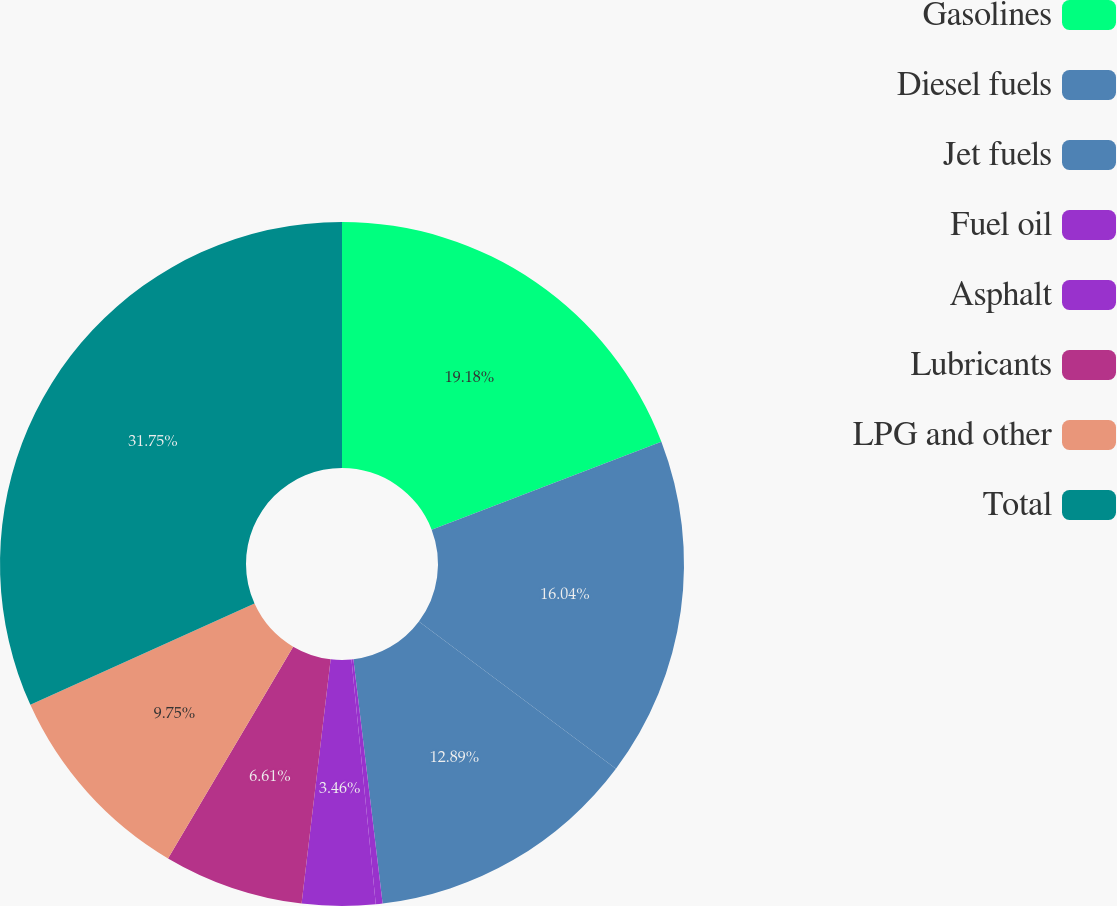<chart> <loc_0><loc_0><loc_500><loc_500><pie_chart><fcel>Gasolines<fcel>Diesel fuels<fcel>Jet fuels<fcel>Fuel oil<fcel>Asphalt<fcel>Lubricants<fcel>LPG and other<fcel>Total<nl><fcel>19.18%<fcel>16.04%<fcel>12.89%<fcel>0.32%<fcel>3.46%<fcel>6.61%<fcel>9.75%<fcel>31.76%<nl></chart> 